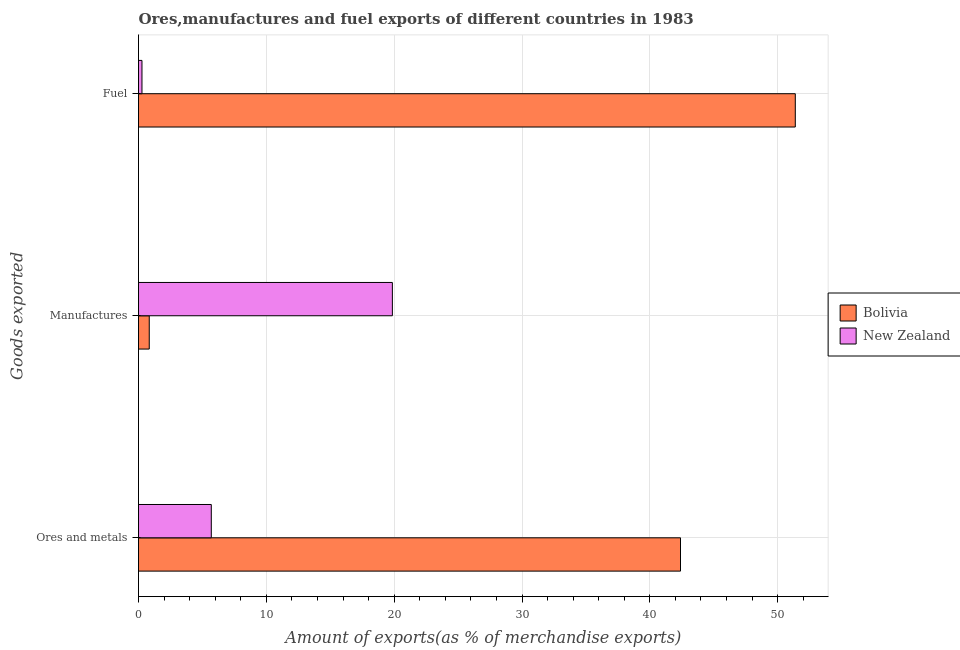How many different coloured bars are there?
Keep it short and to the point. 2. What is the label of the 1st group of bars from the top?
Your answer should be very brief. Fuel. What is the percentage of manufactures exports in Bolivia?
Give a very brief answer. 0.84. Across all countries, what is the maximum percentage of ores and metals exports?
Ensure brevity in your answer.  42.4. Across all countries, what is the minimum percentage of fuel exports?
Offer a very short reply. 0.27. In which country was the percentage of manufactures exports maximum?
Keep it short and to the point. New Zealand. In which country was the percentage of manufactures exports minimum?
Offer a terse response. Bolivia. What is the total percentage of fuel exports in the graph?
Provide a succinct answer. 51.65. What is the difference between the percentage of fuel exports in Bolivia and that in New Zealand?
Your answer should be compact. 51.11. What is the difference between the percentage of ores and metals exports in New Zealand and the percentage of fuel exports in Bolivia?
Keep it short and to the point. -45.69. What is the average percentage of ores and metals exports per country?
Offer a very short reply. 24.05. What is the difference between the percentage of manufactures exports and percentage of fuel exports in Bolivia?
Offer a very short reply. -50.54. What is the ratio of the percentage of ores and metals exports in Bolivia to that in New Zealand?
Offer a very short reply. 7.45. Is the percentage of ores and metals exports in Bolivia less than that in New Zealand?
Make the answer very short. No. Is the difference between the percentage of fuel exports in New Zealand and Bolivia greater than the difference between the percentage of manufactures exports in New Zealand and Bolivia?
Ensure brevity in your answer.  No. What is the difference between the highest and the second highest percentage of ores and metals exports?
Your response must be concise. 36.71. What is the difference between the highest and the lowest percentage of manufactures exports?
Make the answer very short. 19.02. Is the sum of the percentage of ores and metals exports in New Zealand and Bolivia greater than the maximum percentage of manufactures exports across all countries?
Your answer should be very brief. Yes. What does the 1st bar from the top in Ores and metals represents?
Provide a succinct answer. New Zealand. What does the 2nd bar from the bottom in Fuel represents?
Offer a very short reply. New Zealand. Are all the bars in the graph horizontal?
Your response must be concise. Yes. How many countries are there in the graph?
Ensure brevity in your answer.  2. Does the graph contain any zero values?
Give a very brief answer. No. Where does the legend appear in the graph?
Offer a terse response. Center right. What is the title of the graph?
Your response must be concise. Ores,manufactures and fuel exports of different countries in 1983. What is the label or title of the X-axis?
Offer a terse response. Amount of exports(as % of merchandise exports). What is the label or title of the Y-axis?
Keep it short and to the point. Goods exported. What is the Amount of exports(as % of merchandise exports) in Bolivia in Ores and metals?
Provide a short and direct response. 42.4. What is the Amount of exports(as % of merchandise exports) in New Zealand in Ores and metals?
Provide a succinct answer. 5.69. What is the Amount of exports(as % of merchandise exports) of Bolivia in Manufactures?
Your response must be concise. 0.84. What is the Amount of exports(as % of merchandise exports) of New Zealand in Manufactures?
Your response must be concise. 19.86. What is the Amount of exports(as % of merchandise exports) of Bolivia in Fuel?
Ensure brevity in your answer.  51.38. What is the Amount of exports(as % of merchandise exports) of New Zealand in Fuel?
Make the answer very short. 0.27. Across all Goods exported, what is the maximum Amount of exports(as % of merchandise exports) of Bolivia?
Offer a terse response. 51.38. Across all Goods exported, what is the maximum Amount of exports(as % of merchandise exports) in New Zealand?
Make the answer very short. 19.86. Across all Goods exported, what is the minimum Amount of exports(as % of merchandise exports) of Bolivia?
Your answer should be compact. 0.84. Across all Goods exported, what is the minimum Amount of exports(as % of merchandise exports) in New Zealand?
Provide a short and direct response. 0.27. What is the total Amount of exports(as % of merchandise exports) in Bolivia in the graph?
Your answer should be compact. 94.62. What is the total Amount of exports(as % of merchandise exports) of New Zealand in the graph?
Give a very brief answer. 25.82. What is the difference between the Amount of exports(as % of merchandise exports) in Bolivia in Ores and metals and that in Manufactures?
Your response must be concise. 41.56. What is the difference between the Amount of exports(as % of merchandise exports) in New Zealand in Ores and metals and that in Manufactures?
Your answer should be compact. -14.17. What is the difference between the Amount of exports(as % of merchandise exports) in Bolivia in Ores and metals and that in Fuel?
Offer a terse response. -8.98. What is the difference between the Amount of exports(as % of merchandise exports) of New Zealand in Ores and metals and that in Fuel?
Make the answer very short. 5.42. What is the difference between the Amount of exports(as % of merchandise exports) of Bolivia in Manufactures and that in Fuel?
Ensure brevity in your answer.  -50.54. What is the difference between the Amount of exports(as % of merchandise exports) in New Zealand in Manufactures and that in Fuel?
Ensure brevity in your answer.  19.59. What is the difference between the Amount of exports(as % of merchandise exports) in Bolivia in Ores and metals and the Amount of exports(as % of merchandise exports) in New Zealand in Manufactures?
Ensure brevity in your answer.  22.54. What is the difference between the Amount of exports(as % of merchandise exports) in Bolivia in Ores and metals and the Amount of exports(as % of merchandise exports) in New Zealand in Fuel?
Keep it short and to the point. 42.13. What is the difference between the Amount of exports(as % of merchandise exports) in Bolivia in Manufactures and the Amount of exports(as % of merchandise exports) in New Zealand in Fuel?
Make the answer very short. 0.57. What is the average Amount of exports(as % of merchandise exports) in Bolivia per Goods exported?
Your response must be concise. 31.54. What is the average Amount of exports(as % of merchandise exports) of New Zealand per Goods exported?
Keep it short and to the point. 8.61. What is the difference between the Amount of exports(as % of merchandise exports) in Bolivia and Amount of exports(as % of merchandise exports) in New Zealand in Ores and metals?
Offer a very short reply. 36.71. What is the difference between the Amount of exports(as % of merchandise exports) in Bolivia and Amount of exports(as % of merchandise exports) in New Zealand in Manufactures?
Keep it short and to the point. -19.02. What is the difference between the Amount of exports(as % of merchandise exports) of Bolivia and Amount of exports(as % of merchandise exports) of New Zealand in Fuel?
Make the answer very short. 51.11. What is the ratio of the Amount of exports(as % of merchandise exports) in Bolivia in Ores and metals to that in Manufactures?
Offer a very short reply. 50.47. What is the ratio of the Amount of exports(as % of merchandise exports) in New Zealand in Ores and metals to that in Manufactures?
Ensure brevity in your answer.  0.29. What is the ratio of the Amount of exports(as % of merchandise exports) of Bolivia in Ores and metals to that in Fuel?
Offer a terse response. 0.83. What is the ratio of the Amount of exports(as % of merchandise exports) of New Zealand in Ores and metals to that in Fuel?
Your response must be concise. 21.08. What is the ratio of the Amount of exports(as % of merchandise exports) in Bolivia in Manufactures to that in Fuel?
Offer a very short reply. 0.02. What is the ratio of the Amount of exports(as % of merchandise exports) in New Zealand in Manufactures to that in Fuel?
Provide a short and direct response. 73.53. What is the difference between the highest and the second highest Amount of exports(as % of merchandise exports) of Bolivia?
Ensure brevity in your answer.  8.98. What is the difference between the highest and the second highest Amount of exports(as % of merchandise exports) of New Zealand?
Keep it short and to the point. 14.17. What is the difference between the highest and the lowest Amount of exports(as % of merchandise exports) in Bolivia?
Ensure brevity in your answer.  50.54. What is the difference between the highest and the lowest Amount of exports(as % of merchandise exports) of New Zealand?
Offer a terse response. 19.59. 